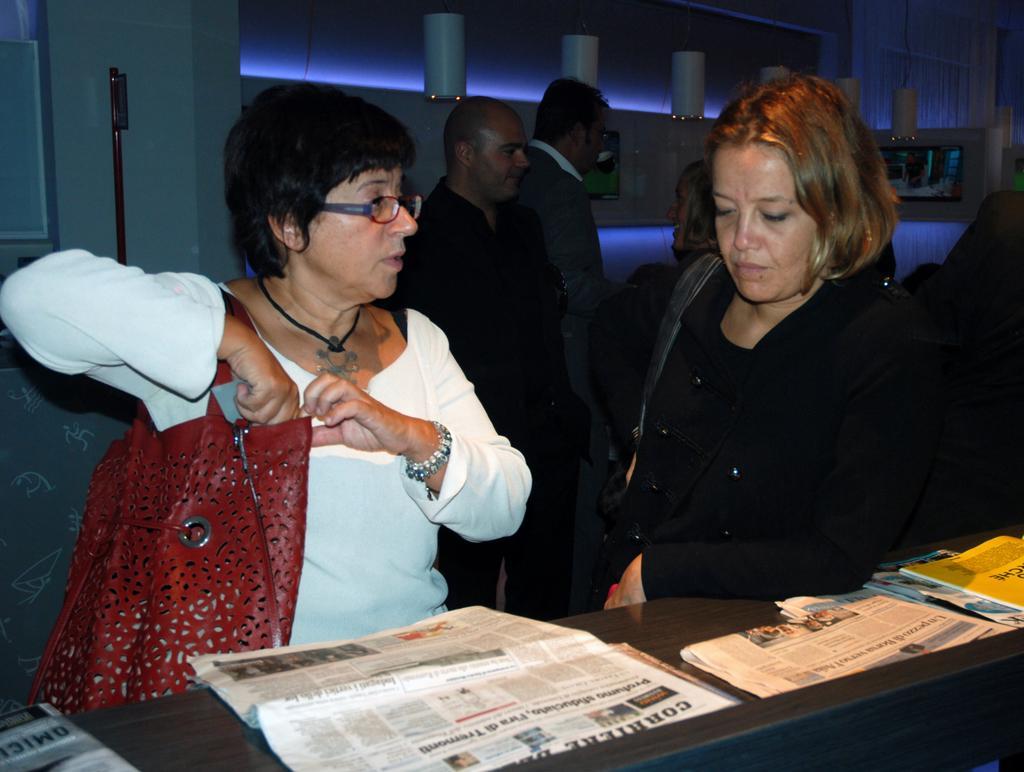Describe this image in one or two sentences. This image consists of two women standing in the front. On the left, the woman is wearing a handbag. On the right, the woman is wearing a black dress. In the background, there are many people. And we can see the pillars along with the wall. At the bottom, there is a table on which there are newspapers and books kept. 